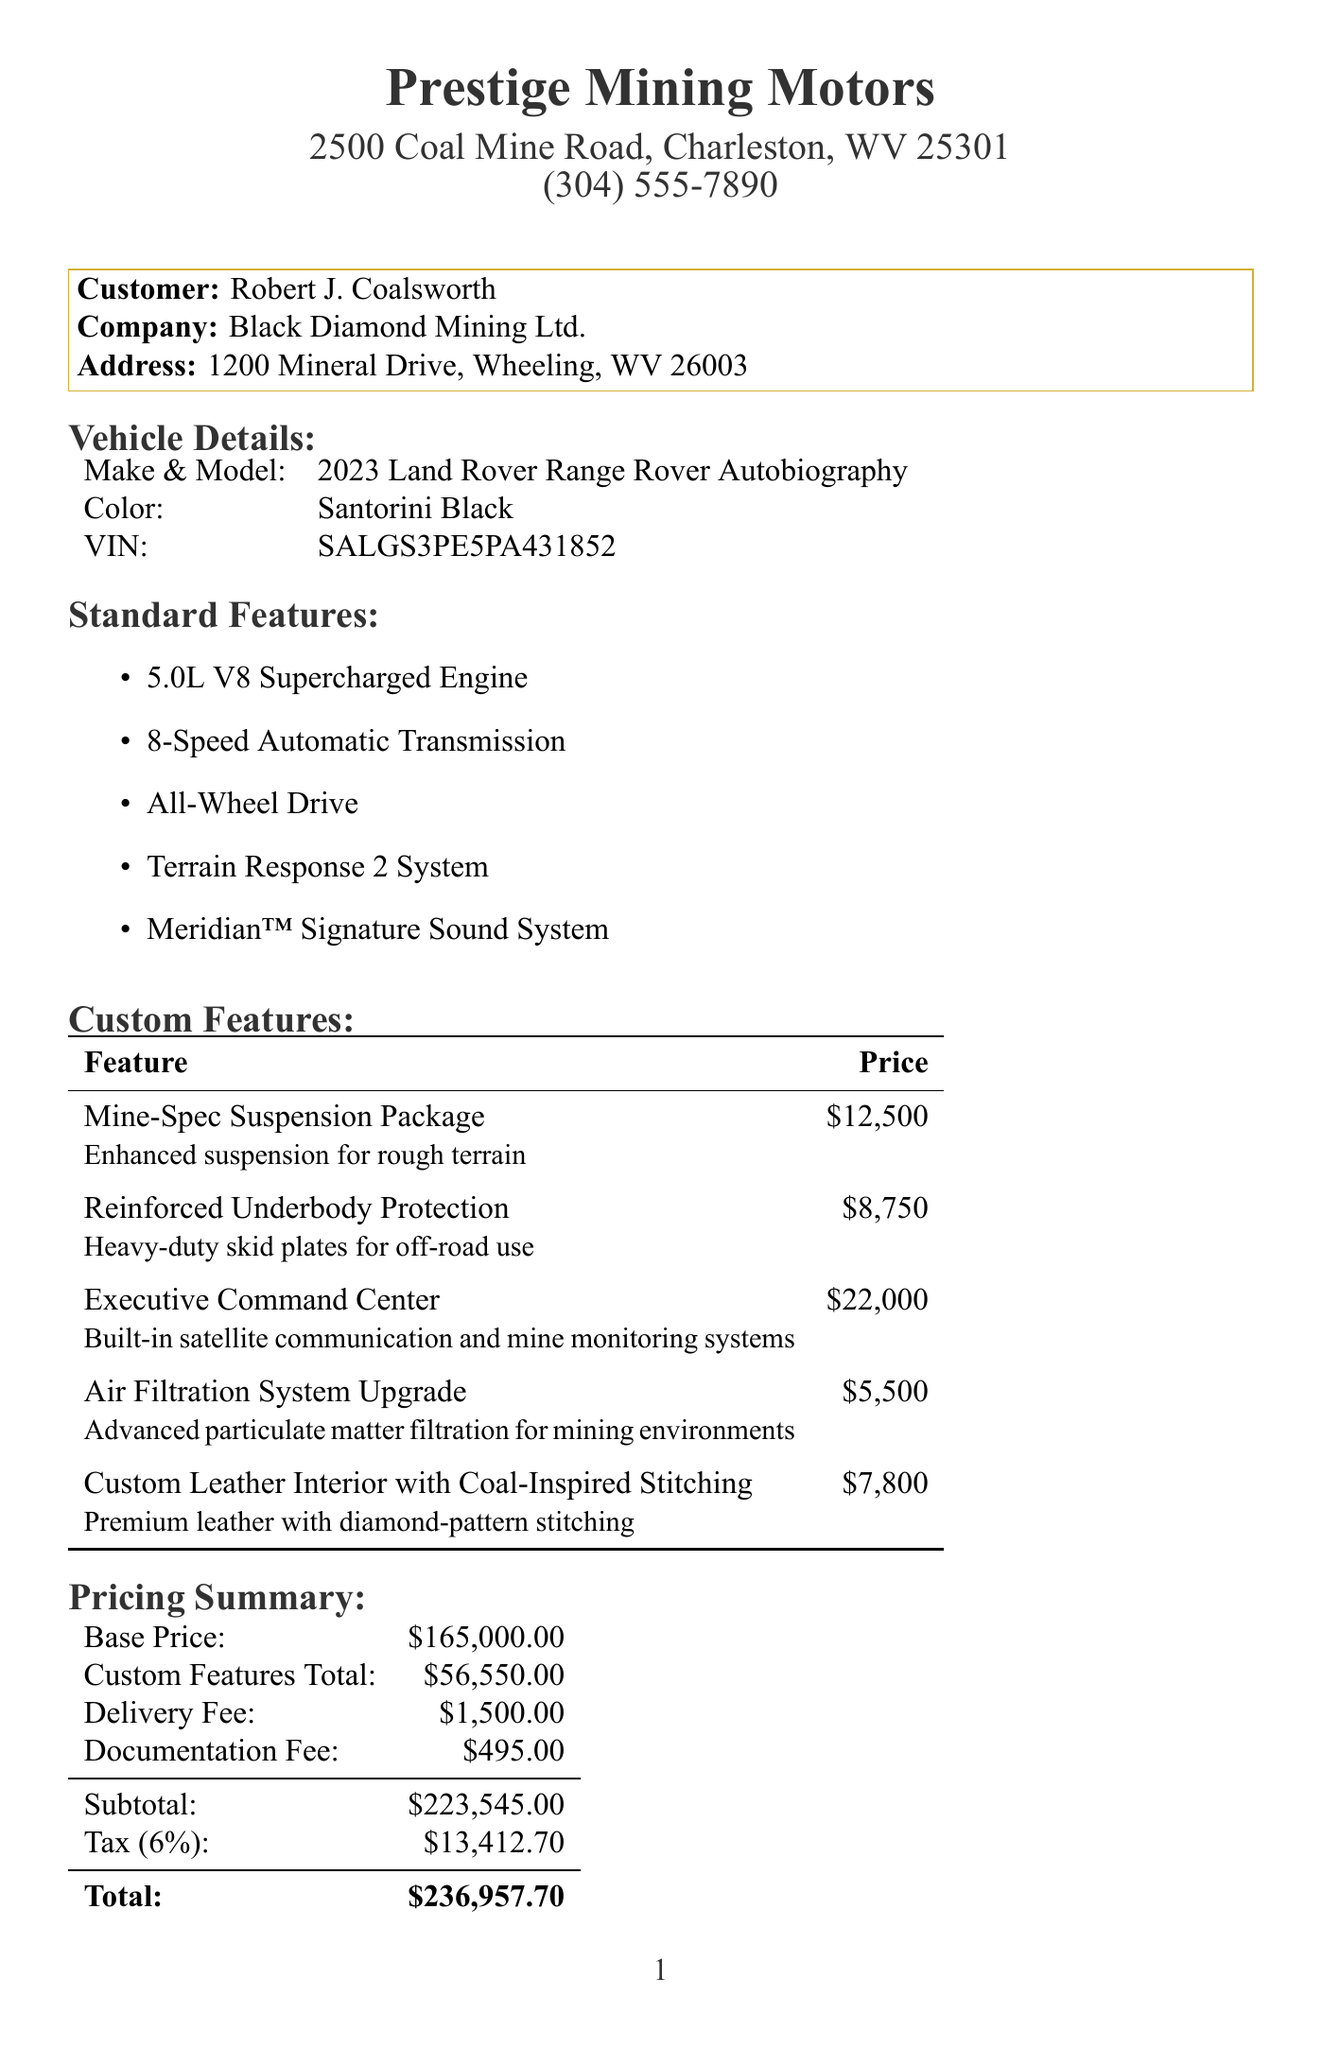What is the dealership name? The dealership name can be found at the top of the receipt.
Answer: Prestige Mining Motors Who is the customer? The customer’s name is listed in the customer section of the document.
Answer: Robert J. Coalsworth What is the total price of the vehicle? The total price is calculated at the end of the document.
Answer: $236,957.70 What is the price of the Executive Command Center feature? The price of custom features is detailed in the custom features section.
Answer: $22,000 What year is the vehicle? The year of the vehicle is mentioned in the vehicle details section.
Answer: 2023 What payment method was used? The payment method is specified in the payment details section.
Answer: Wire Transfer How much is the delivery fee? The delivery fee is listed in the pricing summary.
Answer: $1,500.00 How many years is the complimentary maintenance package valid for? The duration of the maintenance package is noted in the additional notes.
Answer: 3 years What color is the vehicle? The color of the vehicle is mentioned in the vehicle details section.
Answer: Santorini Black What custom feature provides advanced filtration for mining environments? The relevant custom feature is described in the custom features section.
Answer: Air Filtration System Upgrade 